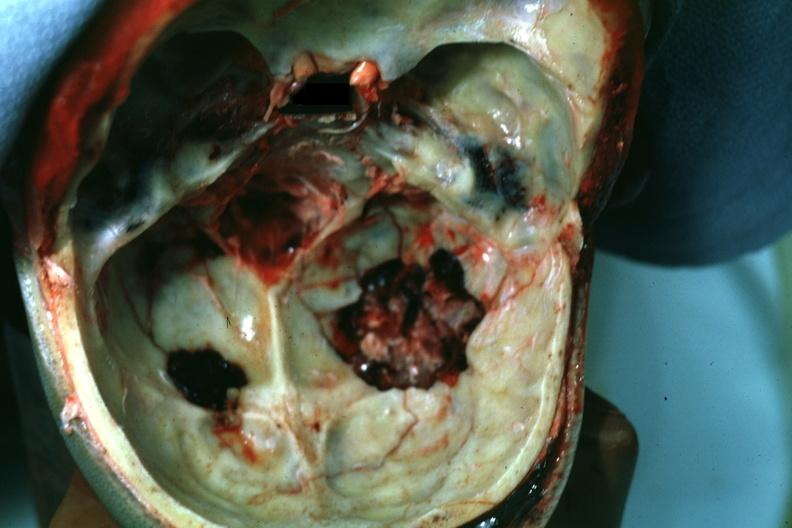what is present?
Answer the question using a single word or phrase. Basilar skull fracture 